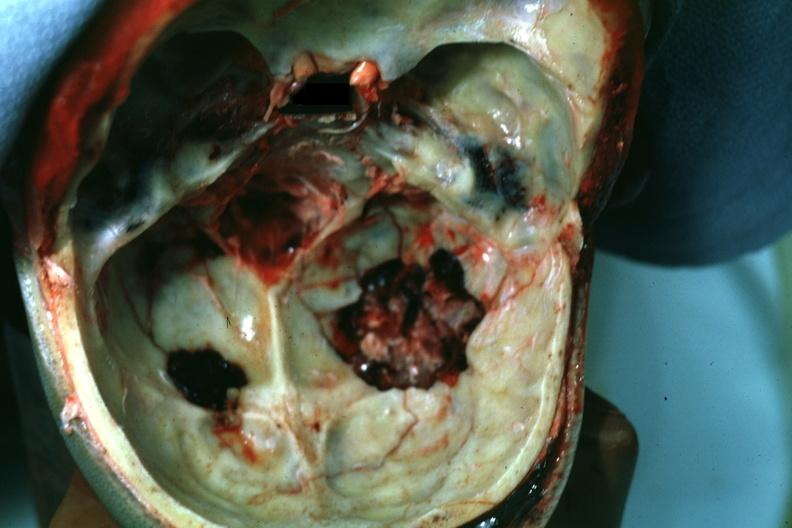what is present?
Answer the question using a single word or phrase. Basilar skull fracture 